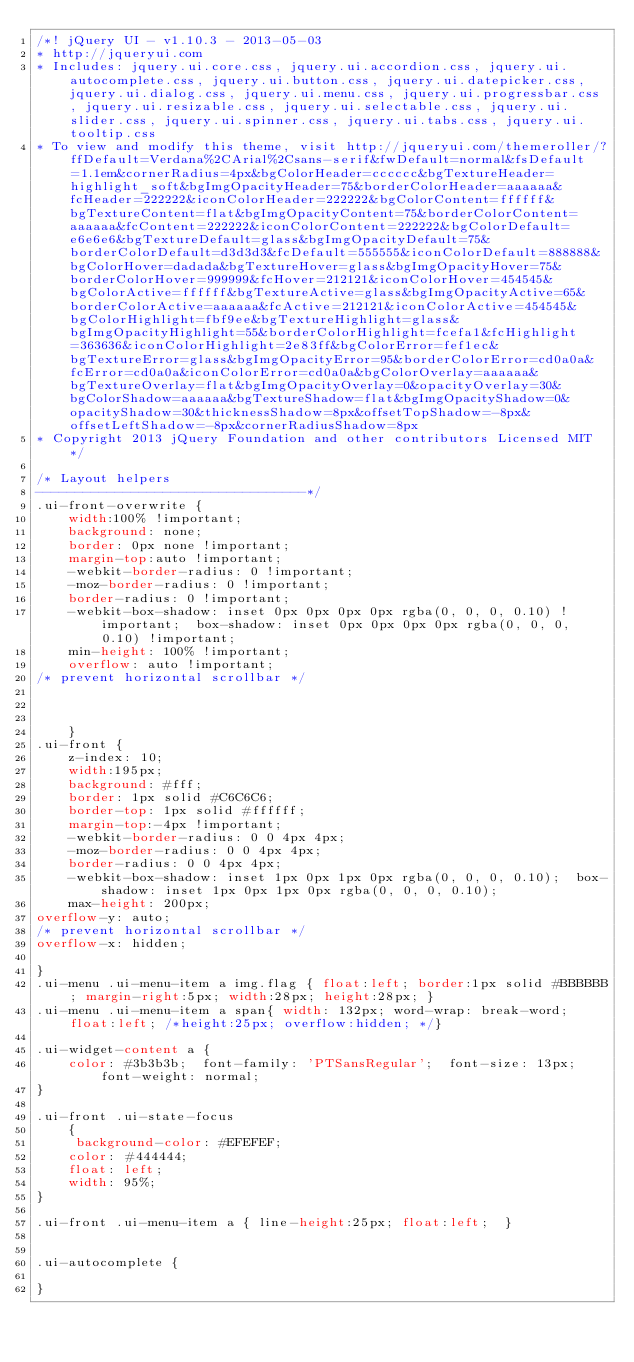Convert code to text. <code><loc_0><loc_0><loc_500><loc_500><_CSS_>/*! jQuery UI - v1.10.3 - 2013-05-03
* http://jqueryui.com
* Includes: jquery.ui.core.css, jquery.ui.accordion.css, jquery.ui.autocomplete.css, jquery.ui.button.css, jquery.ui.datepicker.css, jquery.ui.dialog.css, jquery.ui.menu.css, jquery.ui.progressbar.css, jquery.ui.resizable.css, jquery.ui.selectable.css, jquery.ui.slider.css, jquery.ui.spinner.css, jquery.ui.tabs.css, jquery.ui.tooltip.css
* To view and modify this theme, visit http://jqueryui.com/themeroller/?ffDefault=Verdana%2CArial%2Csans-serif&fwDefault=normal&fsDefault=1.1em&cornerRadius=4px&bgColorHeader=cccccc&bgTextureHeader=highlight_soft&bgImgOpacityHeader=75&borderColorHeader=aaaaaa&fcHeader=222222&iconColorHeader=222222&bgColorContent=ffffff&bgTextureContent=flat&bgImgOpacityContent=75&borderColorContent=aaaaaa&fcContent=222222&iconColorContent=222222&bgColorDefault=e6e6e6&bgTextureDefault=glass&bgImgOpacityDefault=75&borderColorDefault=d3d3d3&fcDefault=555555&iconColorDefault=888888&bgColorHover=dadada&bgTextureHover=glass&bgImgOpacityHover=75&borderColorHover=999999&fcHover=212121&iconColorHover=454545&bgColorActive=ffffff&bgTextureActive=glass&bgImgOpacityActive=65&borderColorActive=aaaaaa&fcActive=212121&iconColorActive=454545&bgColorHighlight=fbf9ee&bgTextureHighlight=glass&bgImgOpacityHighlight=55&borderColorHighlight=fcefa1&fcHighlight=363636&iconColorHighlight=2e83ff&bgColorError=fef1ec&bgTextureError=glass&bgImgOpacityError=95&borderColorError=cd0a0a&fcError=cd0a0a&iconColorError=cd0a0a&bgColorOverlay=aaaaaa&bgTextureOverlay=flat&bgImgOpacityOverlay=0&opacityOverlay=30&bgColorShadow=aaaaaa&bgTextureShadow=flat&bgImgOpacityShadow=0&opacityShadow=30&thicknessShadow=8px&offsetTopShadow=-8px&offsetLeftShadow=-8px&cornerRadiusShadow=8px
* Copyright 2013 jQuery Foundation and other contributors Licensed MIT */

/* Layout helpers
----------------------------------*/
.ui-front-overwrite {
	width:100% !important;
	background: none;
	border: 0px none !important;
	margin-top:auto !important;
	-webkit-border-radius: 0 !important;
	-moz-border-radius: 0 !important;
	border-radius: 0 !important;
	-webkit-box-shadow: inset 0px 0px 0px 0px rgba(0, 0, 0, 0.10) !important;  box-shadow: inset 0px 0px 0px 0px rgba(0, 0, 0, 0.10) !important;
	min-height: 100% !important;
	overflow: auto !important;
/* prevent horizontal scrollbar */

	
	
	}
.ui-front {
	z-index: 10;
	width:195px;
	background: #fff;
	border: 1px solid #C6C6C6;
	border-top: 1px solid #ffffff;
	margin-top:-4px !important;
	-webkit-border-radius: 0 0 4px 4px;
	-moz-border-radius: 0 0 4px 4px;
	border-radius: 0 0 4px 4px;
	-webkit-box-shadow: inset 1px 0px 1px 0px rgba(0, 0, 0, 0.10);  box-shadow: inset 1px 0px 1px 0px rgba(0, 0, 0, 0.10);
	max-height: 200px;
overflow-y: auto;
/* prevent horizontal scrollbar */
overflow-x: hidden;
	
}
.ui-menu .ui-menu-item a img.flag { float:left; border:1px solid #BBBBBB; margin-right:5px; width:28px; height:28px; }
.ui-menu .ui-menu-item a span{ width: 132px; word-wrap: break-word; float:left; /*height:25px; overflow:hidden; */}

.ui-widget-content a {
	color: #3b3b3b;  font-family: 'PTSansRegular';  font-size: 13px; font-weight: normal;
}

.ui-front .ui-state-focus
	{	
	 background-color: #EFEFEF;
    color: #444444;
    float: left;
    width: 95%;
}

.ui-front .ui-menu-item a { line-height:25px; float:left;  }


.ui-autocomplete {

}
</code> 